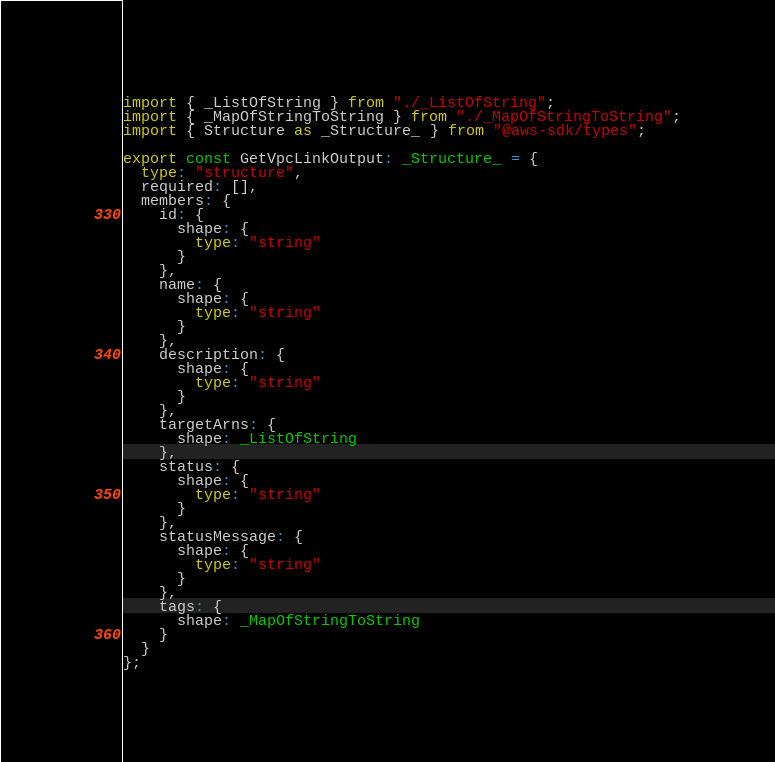Convert code to text. <code><loc_0><loc_0><loc_500><loc_500><_TypeScript_>import { _ListOfString } from "./_ListOfString";
import { _MapOfStringToString } from "./_MapOfStringToString";
import { Structure as _Structure_ } from "@aws-sdk/types";

export const GetVpcLinkOutput: _Structure_ = {
  type: "structure",
  required: [],
  members: {
    id: {
      shape: {
        type: "string"
      }
    },
    name: {
      shape: {
        type: "string"
      }
    },
    description: {
      shape: {
        type: "string"
      }
    },
    targetArns: {
      shape: _ListOfString
    },
    status: {
      shape: {
        type: "string"
      }
    },
    statusMessage: {
      shape: {
        type: "string"
      }
    },
    tags: {
      shape: _MapOfStringToString
    }
  }
};
</code> 